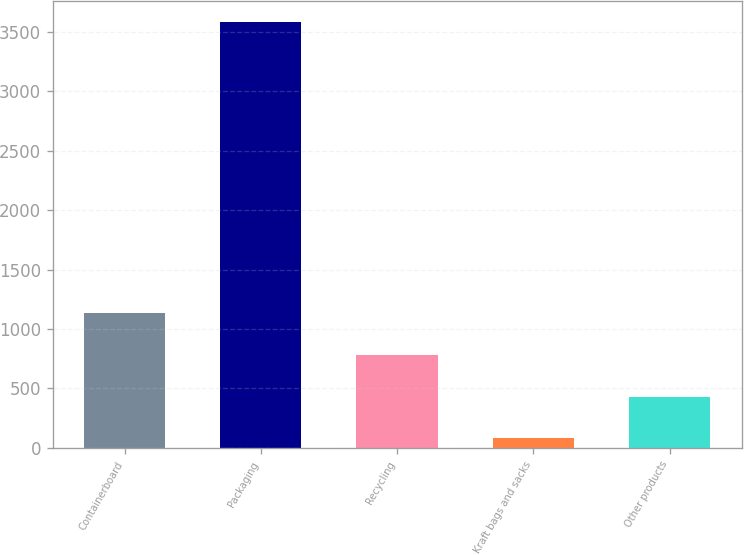Convert chart. <chart><loc_0><loc_0><loc_500><loc_500><bar_chart><fcel>Containerboard<fcel>Packaging<fcel>Recycling<fcel>Kraft bags and sacks<fcel>Other products<nl><fcel>1131.2<fcel>3584<fcel>780.8<fcel>80<fcel>430.4<nl></chart> 